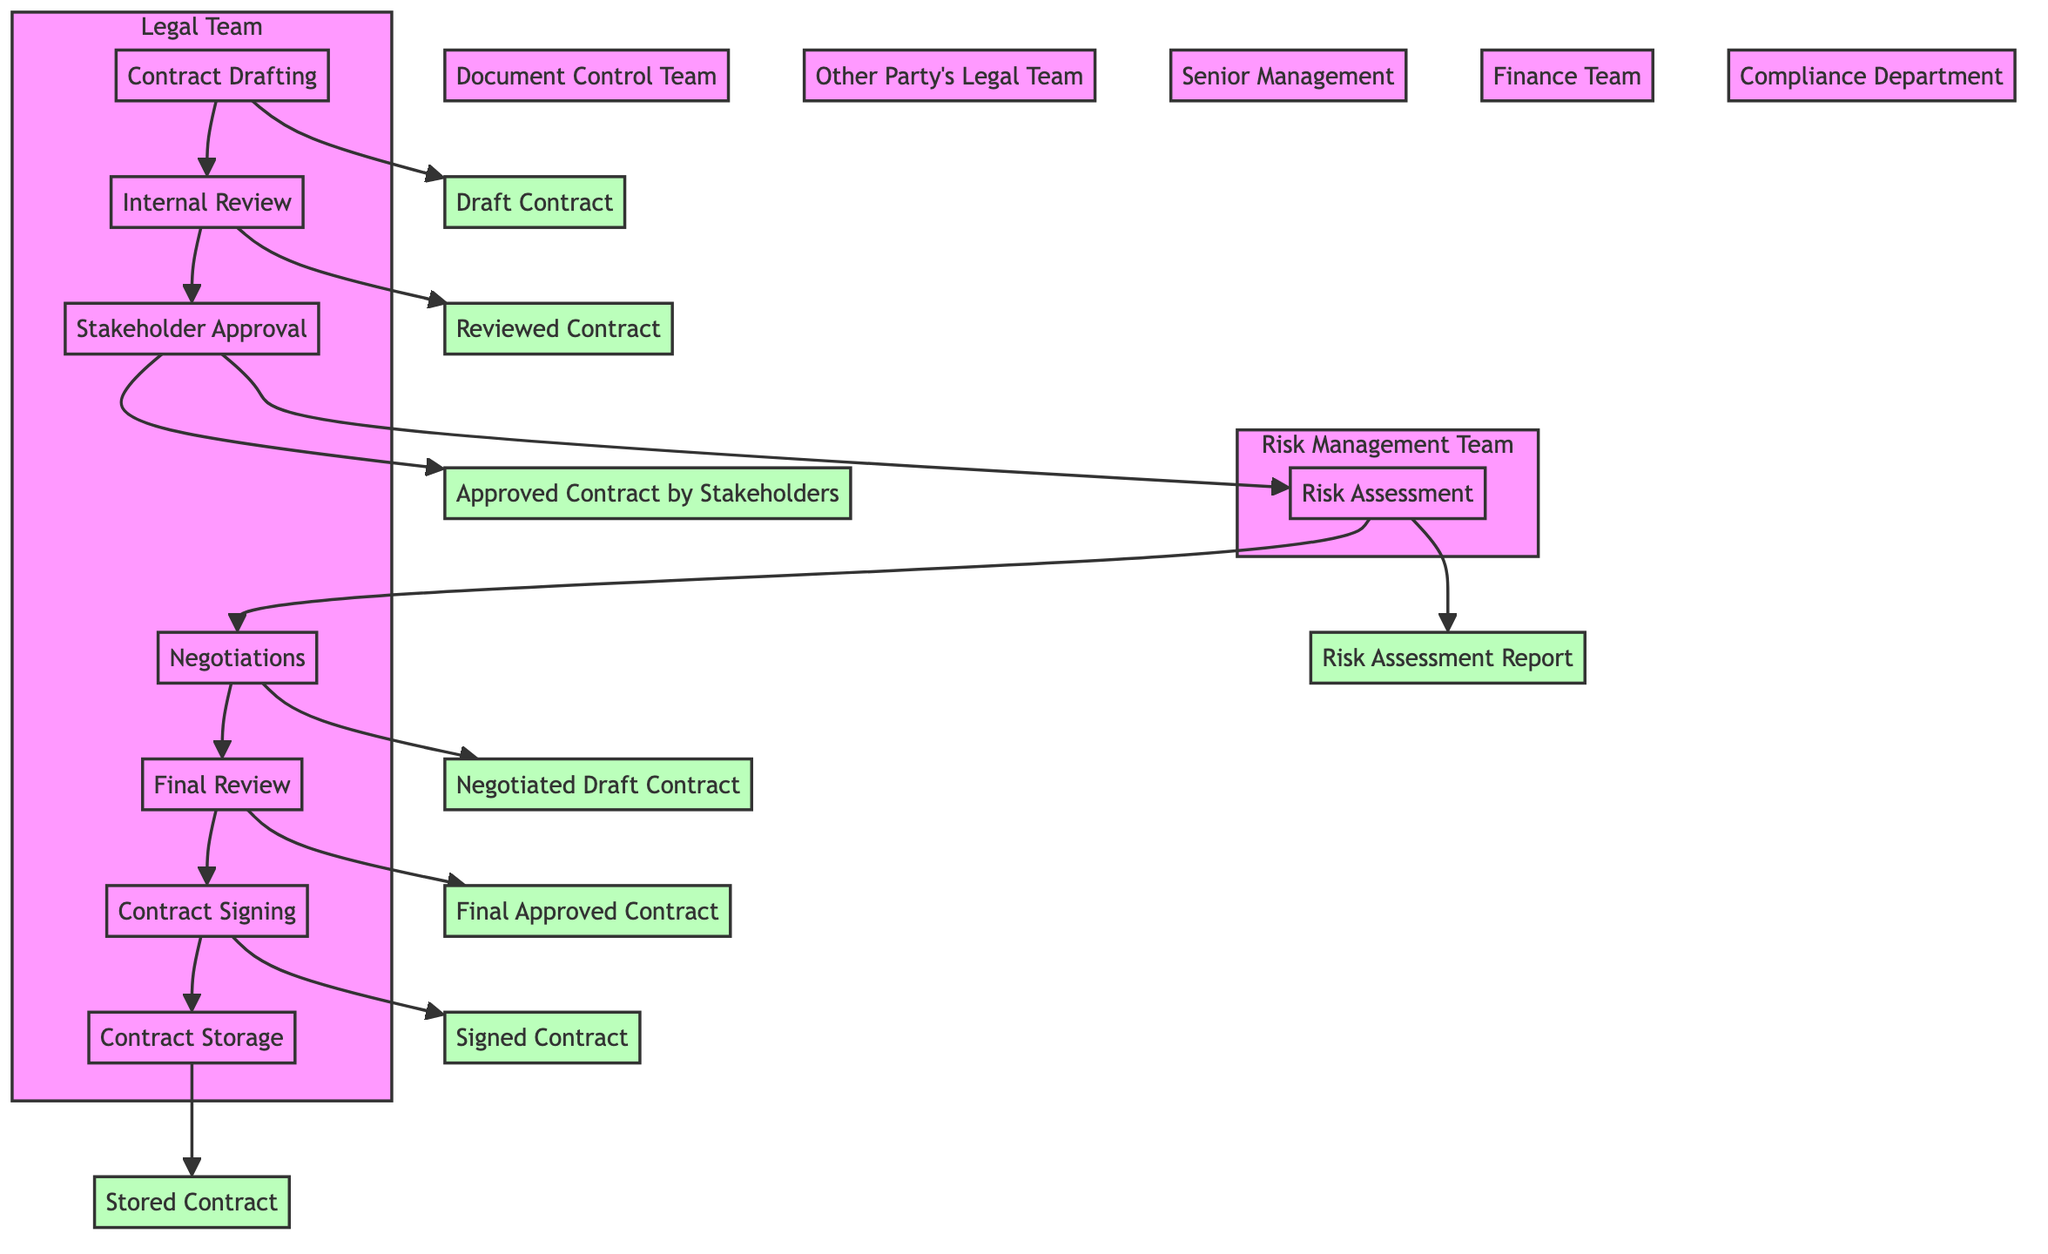What is the first step in the contract review process? The first step listed in the diagram is "Contract Drafting," where the initial draft of the contract is created by the Legal Team.
Answer: Contract Drafting Which teams are involved in the Internal Review step? According to the diagram, the teams involved in the Internal Review step are the Legal Team and the Compliance Department.
Answer: Legal Team, Compliance Department What is the output of the Risk Assessment step? The diagram indicates that the output of the Risk Assessment is a "Risk Assessment Report."
Answer: Risk Assessment Report How many steps are there in the contract approval process? By counting the steps listed in the diagram, there are a total of eight steps in the contract approval process.
Answer: Eight Which party is responsible for the final review of the contract? The final review of the contract is carried out by the Legal Team and Senior Management according to the diagram.
Answer: Legal Team, Senior Management What is the last step before the contract is stored? The last step before the contract is stored is the "Contract Signing," where both parties sign the contract.
Answer: Contract Signing Who is responsible for negotiations with the other party? The diagram states that the negotiations are handled by the Legal Team and the Other Party's Legal Team.
Answer: Legal Team, Other Party's Legal Team What is required before the Final Review can take place? Before the Final Review can take place, the Negotiations must be completed. This indicates that a Negotiated Draft Contract must be available.
Answer: Negotiations Which step follows Stakeholder Approval? The step that follows Stakeholder Approval according to the diagram is "Risk Assessment."
Answer: Risk Assessment 